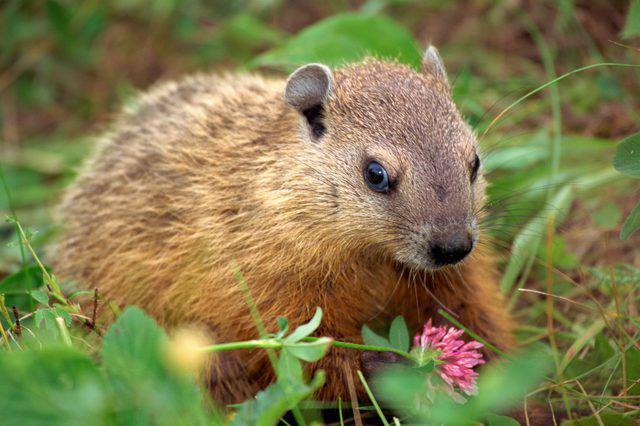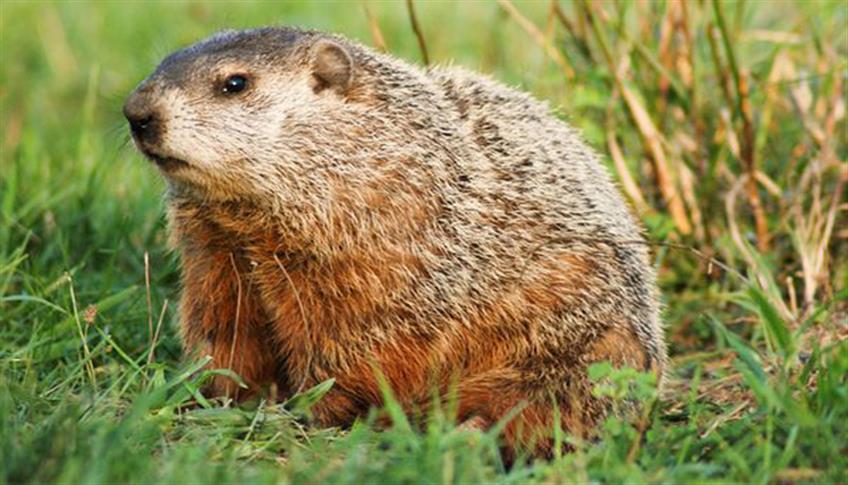The first image is the image on the left, the second image is the image on the right. Evaluate the accuracy of this statement regarding the images: "The left and right image contains the same number of rodents walking on the grass.". Is it true? Answer yes or no. Yes. The first image is the image on the left, the second image is the image on the right. For the images displayed, is the sentence "A marmot is partly in a hole." factually correct? Answer yes or no. No. 